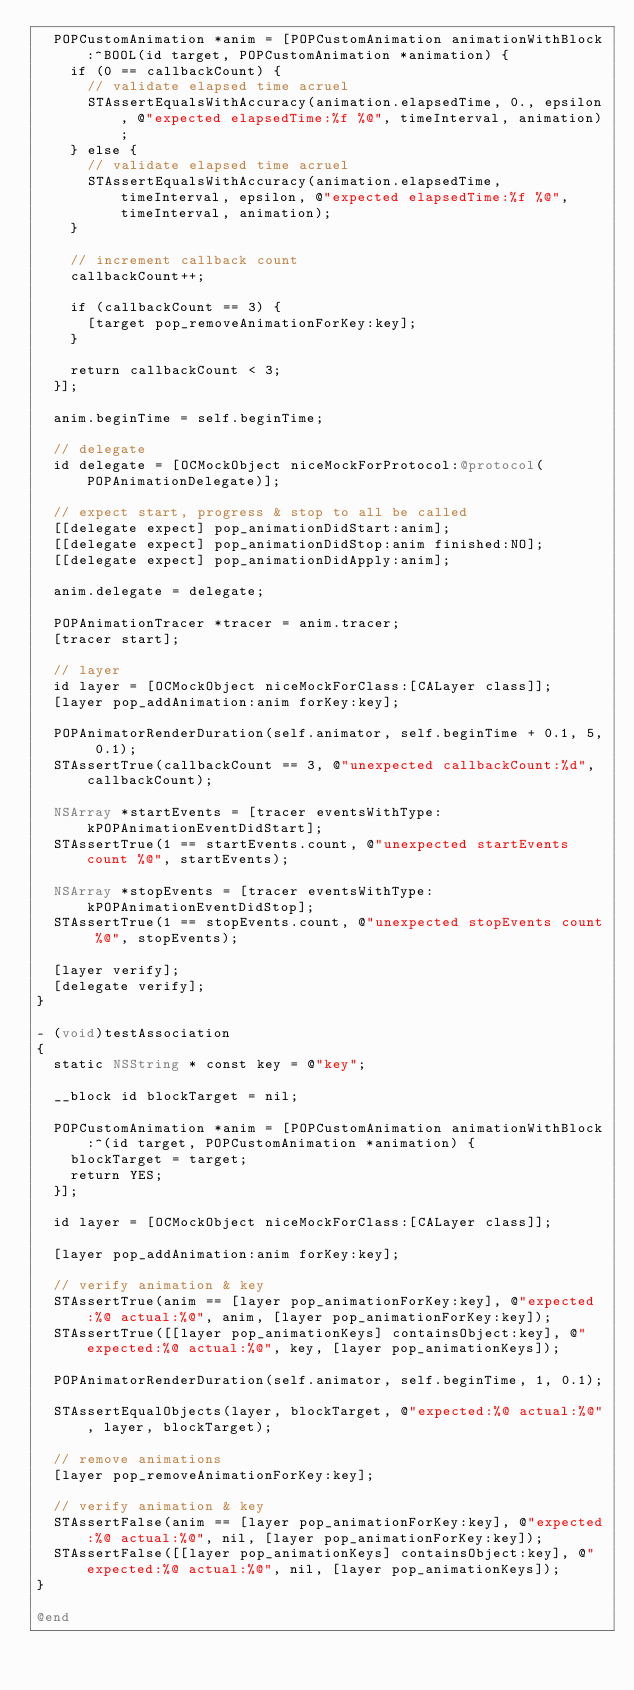<code> <loc_0><loc_0><loc_500><loc_500><_ObjectiveC_>  POPCustomAnimation *anim = [POPCustomAnimation animationWithBlock:^BOOL(id target, POPCustomAnimation *animation) {
    if (0 == callbackCount) {
      // validate elapsed time acruel
      STAssertEqualsWithAccuracy(animation.elapsedTime, 0., epsilon, @"expected elapsedTime:%f %@", timeInterval, animation);
    } else {
      // validate elapsed time acruel
      STAssertEqualsWithAccuracy(animation.elapsedTime, timeInterval, epsilon, @"expected elapsedTime:%f %@", timeInterval, animation);
    }
    
    // increment callback count
    callbackCount++;
    
    if (callbackCount == 3) {
      [target pop_removeAnimationForKey:key];
    }
    
    return callbackCount < 3;
  }];
  
  anim.beginTime = self.beginTime;
  
  // delegate
  id delegate = [OCMockObject niceMockForProtocol:@protocol(POPAnimationDelegate)];
  
  // expect start, progress & stop to all be called
  [[delegate expect] pop_animationDidStart:anim];
  [[delegate expect] pop_animationDidStop:anim finished:NO];
  [[delegate expect] pop_animationDidApply:anim];
  
  anim.delegate = delegate;
  
  POPAnimationTracer *tracer = anim.tracer;
  [tracer start];

  // layer
  id layer = [OCMockObject niceMockForClass:[CALayer class]];
  [layer pop_addAnimation:anim forKey:key];
  
  POPAnimatorRenderDuration(self.animator, self.beginTime + 0.1, 5, 0.1);
  STAssertTrue(callbackCount == 3, @"unexpected callbackCount:%d", callbackCount);

  NSArray *startEvents = [tracer eventsWithType:kPOPAnimationEventDidStart];
  STAssertTrue(1 == startEvents.count, @"unexpected startEvents count %@", startEvents);
  
  NSArray *stopEvents = [tracer eventsWithType:kPOPAnimationEventDidStop];
  STAssertTrue(1 == stopEvents.count, @"unexpected stopEvents count %@", stopEvents);
  
  [layer verify];
  [delegate verify];
}

- (void)testAssociation
{
  static NSString * const key = @"key";
  
  __block id blockTarget = nil;
  
  POPCustomAnimation *anim = [POPCustomAnimation animationWithBlock:^(id target, POPCustomAnimation *animation) {
    blockTarget = target;
    return YES;
  }];

  id layer = [OCMockObject niceMockForClass:[CALayer class]];

  [layer pop_addAnimation:anim forKey:key];
  
  // verify animation & key
  STAssertTrue(anim == [layer pop_animationForKey:key], @"expected:%@ actual:%@", anim, [layer pop_animationForKey:key]);
  STAssertTrue([[layer pop_animationKeys] containsObject:key], @"expected:%@ actual:%@", key, [layer pop_animationKeys]);
  
  POPAnimatorRenderDuration(self.animator, self.beginTime, 1, 0.1);

  STAssertEqualObjects(layer, blockTarget, @"expected:%@ actual:%@", layer, blockTarget);
  
  // remove animations
  [layer pop_removeAnimationForKey:key];

  // verify animation & key
  STAssertFalse(anim == [layer pop_animationForKey:key], @"expected:%@ actual:%@", nil, [layer pop_animationForKey:key]);
  STAssertFalse([[layer pop_animationKeys] containsObject:key], @"expected:%@ actual:%@", nil, [layer pop_animationKeys]);
}

@end
</code> 